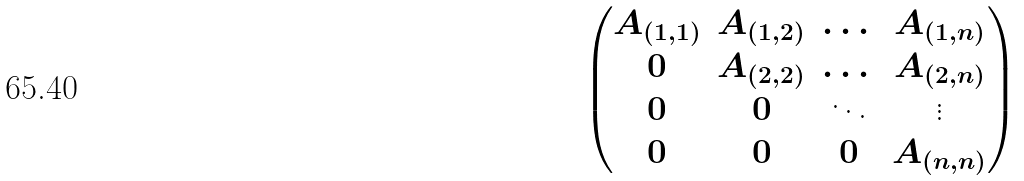<formula> <loc_0><loc_0><loc_500><loc_500>\begin{pmatrix} A _ { ( 1 , 1 ) } & A _ { ( 1 , 2 ) } & \dots & A _ { ( 1 , n ) } \\ 0 & A _ { ( 2 , 2 ) } & \dots & A _ { ( 2 , n ) } \\ 0 & 0 & \ddots & \vdots \\ 0 & 0 & 0 & A _ { ( n , n ) } \end{pmatrix}</formula> 